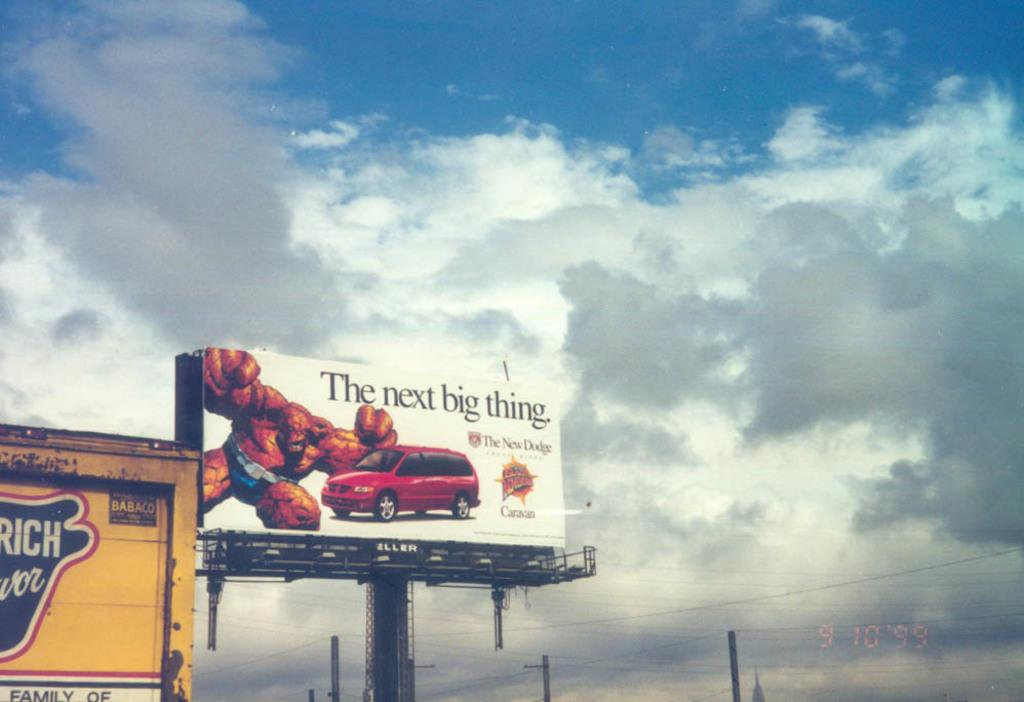<image>
Relay a brief, clear account of the picture shown. The new Dodge is the next big thing. 